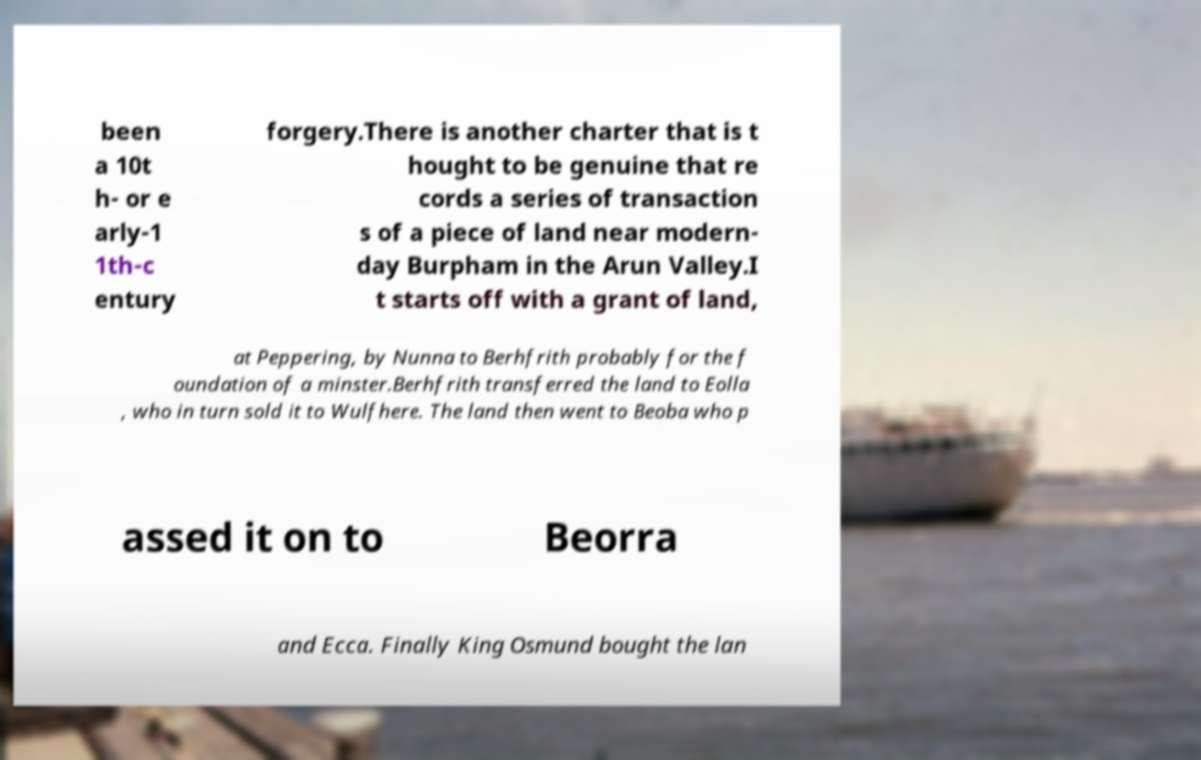What messages or text are displayed in this image? I need them in a readable, typed format. been a 10t h- or e arly-1 1th-c entury forgery.There is another charter that is t hought to be genuine that re cords a series of transaction s of a piece of land near modern- day Burpham in the Arun Valley.I t starts off with a grant of land, at Peppering, by Nunna to Berhfrith probably for the f oundation of a minster.Berhfrith transferred the land to Eolla , who in turn sold it to Wulfhere. The land then went to Beoba who p assed it on to Beorra and Ecca. Finally King Osmund bought the lan 